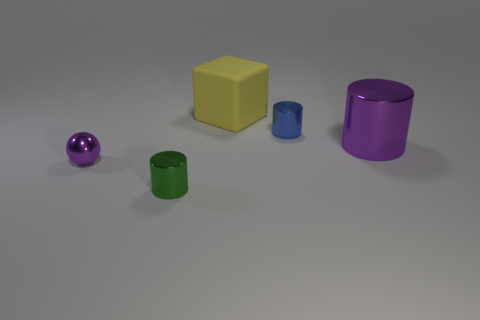Subtract all purple cylinders. How many cylinders are left? 2 Add 2 small blue cylinders. How many objects exist? 7 Subtract all blue cylinders. How many cylinders are left? 2 Subtract all balls. How many objects are left? 4 Subtract all yellow cylinders. How many green blocks are left? 0 Subtract all small yellow cubes. Subtract all yellow blocks. How many objects are left? 4 Add 5 blue cylinders. How many blue cylinders are left? 6 Add 5 small purple metallic balls. How many small purple metallic balls exist? 6 Subtract 0 blue spheres. How many objects are left? 5 Subtract all gray cubes. Subtract all cyan cylinders. How many cubes are left? 1 